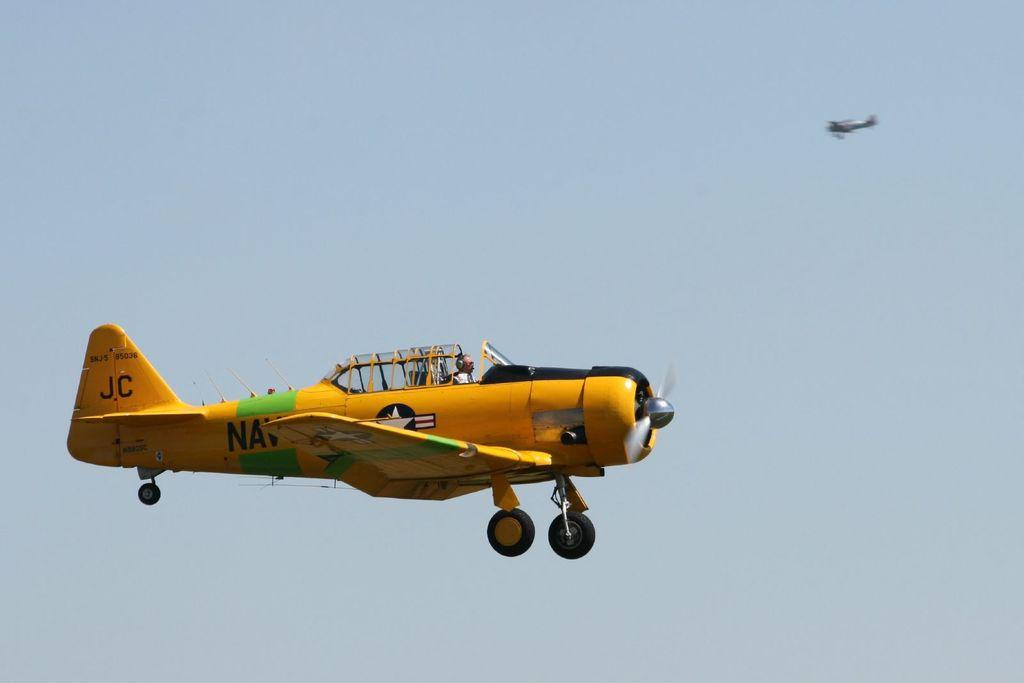<image>
Create a compact narrative representing the image presented. the letters JC that are on a plane 